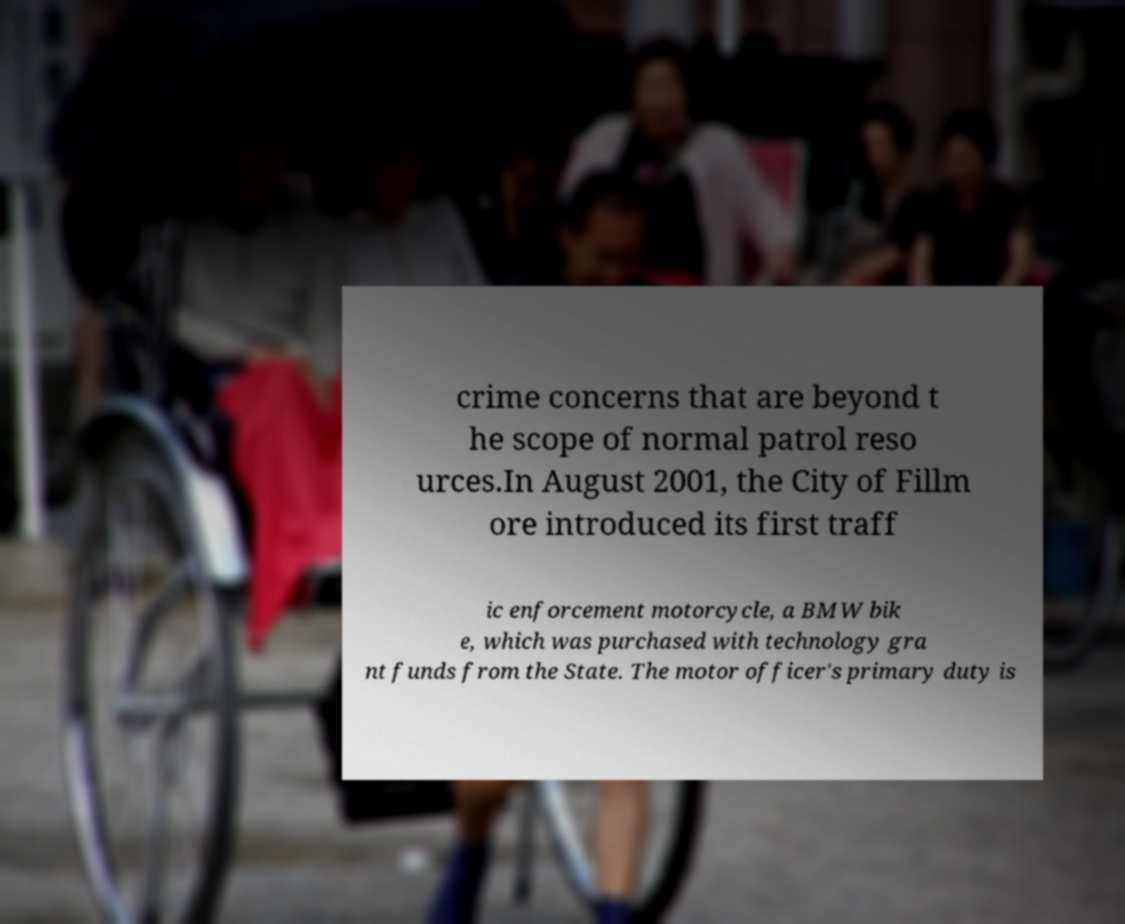Could you assist in decoding the text presented in this image and type it out clearly? crime concerns that are beyond t he scope of normal patrol reso urces.In August 2001, the City of Fillm ore introduced its first traff ic enforcement motorcycle, a BMW bik e, which was purchased with technology gra nt funds from the State. The motor officer's primary duty is 